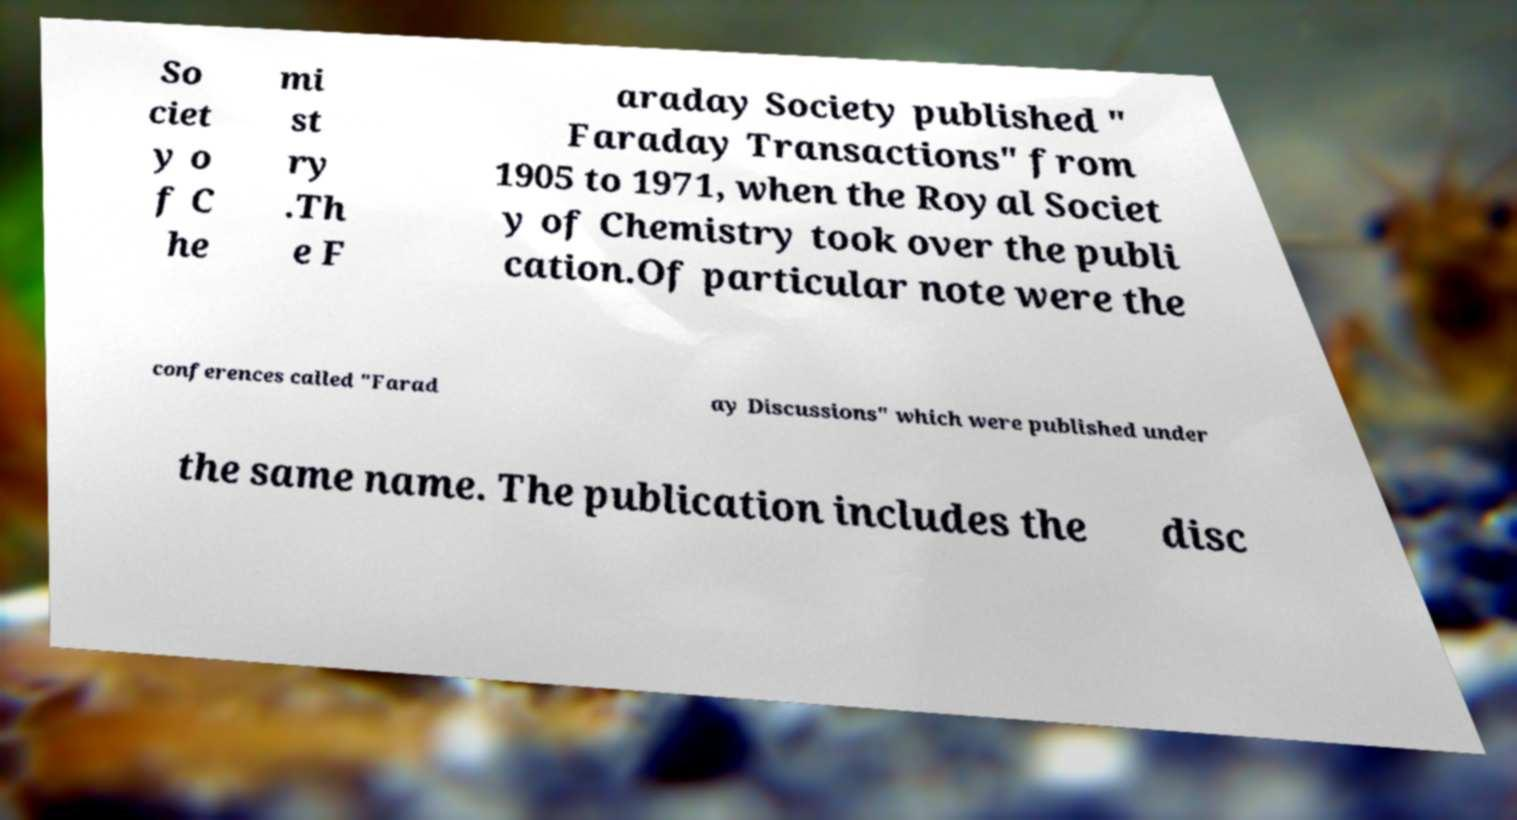Please identify and transcribe the text found in this image. So ciet y o f C he mi st ry .Th e F araday Society published " Faraday Transactions" from 1905 to 1971, when the Royal Societ y of Chemistry took over the publi cation.Of particular note were the conferences called "Farad ay Discussions" which were published under the same name. The publication includes the disc 